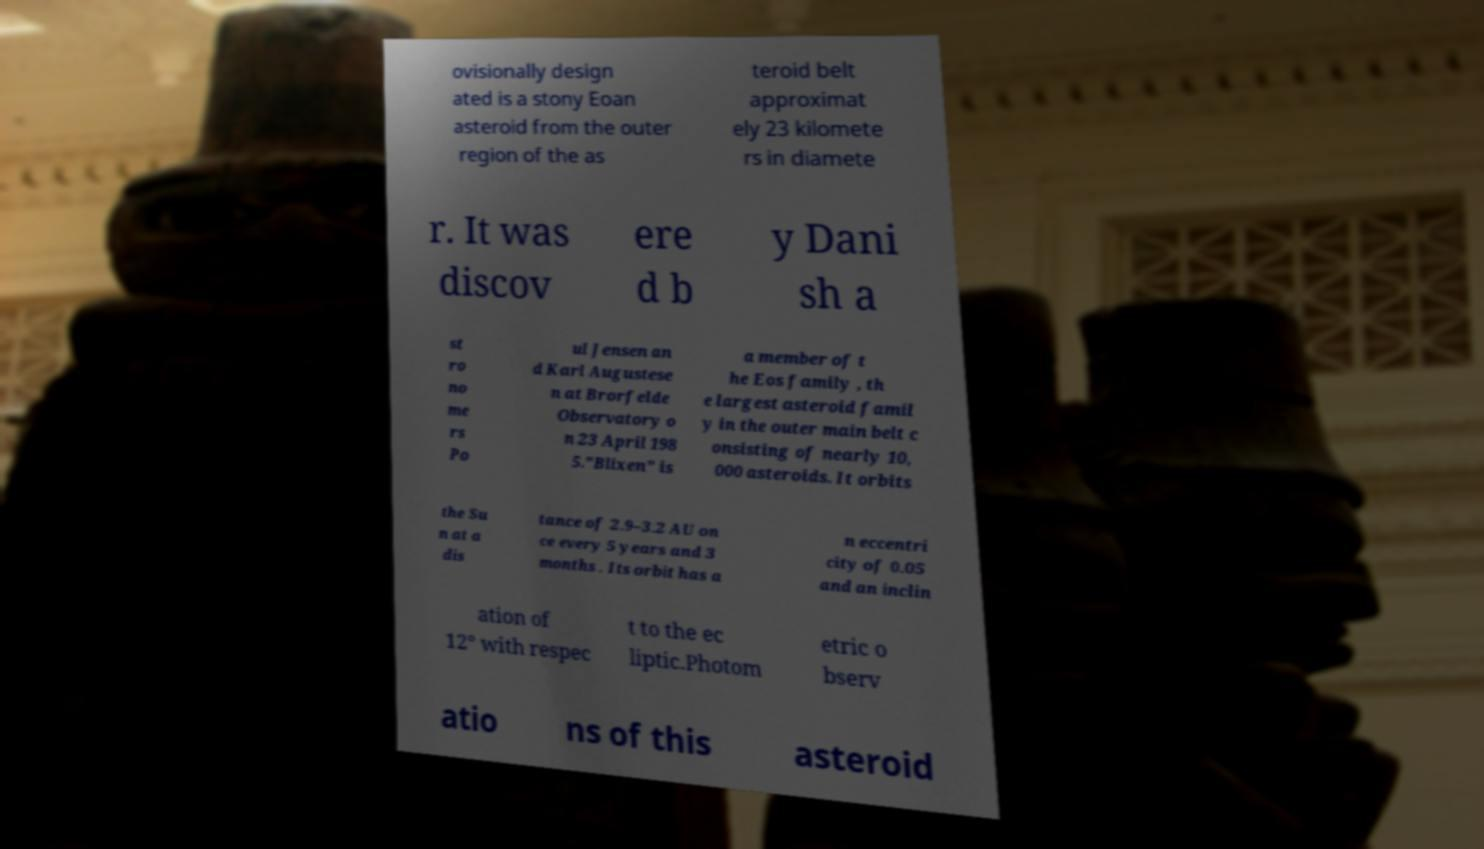Please read and relay the text visible in this image. What does it say? ovisionally design ated is a stony Eoan asteroid from the outer region of the as teroid belt approximat ely 23 kilomete rs in diamete r. It was discov ere d b y Dani sh a st ro no me rs Po ul Jensen an d Karl Augustese n at Brorfelde Observatory o n 23 April 198 5."Blixen" is a member of t he Eos family , th e largest asteroid famil y in the outer main belt c onsisting of nearly 10, 000 asteroids. It orbits the Su n at a dis tance of 2.9–3.2 AU on ce every 5 years and 3 months . Its orbit has a n eccentri city of 0.05 and an inclin ation of 12° with respec t to the ec liptic.Photom etric o bserv atio ns of this asteroid 